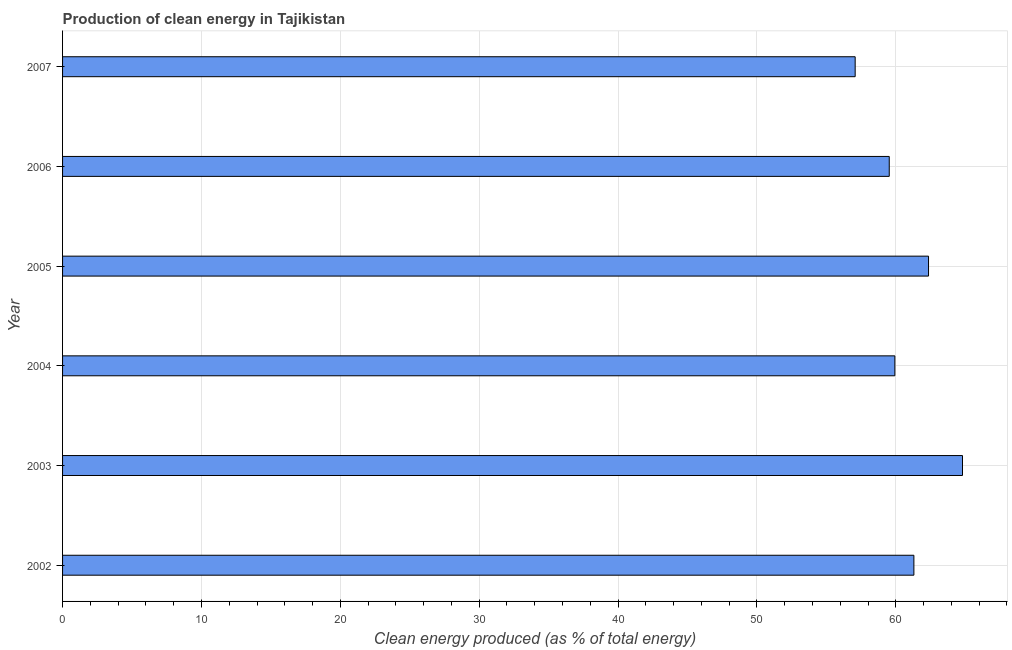Does the graph contain grids?
Provide a succinct answer. Yes. What is the title of the graph?
Your response must be concise. Production of clean energy in Tajikistan. What is the label or title of the X-axis?
Keep it short and to the point. Clean energy produced (as % of total energy). What is the production of clean energy in 2002?
Provide a short and direct response. 61.3. Across all years, what is the maximum production of clean energy?
Make the answer very short. 64.8. Across all years, what is the minimum production of clean energy?
Your answer should be very brief. 57.07. What is the sum of the production of clean energy?
Ensure brevity in your answer.  364.99. What is the difference between the production of clean energy in 2003 and 2006?
Offer a terse response. 5.27. What is the average production of clean energy per year?
Make the answer very short. 60.83. What is the median production of clean energy?
Give a very brief answer. 60.62. Do a majority of the years between 2003 and 2005 (inclusive) have production of clean energy greater than 20 %?
Give a very brief answer. Yes. Is the production of clean energy in 2005 less than that in 2007?
Ensure brevity in your answer.  No. Is the difference between the production of clean energy in 2004 and 2007 greater than the difference between any two years?
Provide a short and direct response. No. What is the difference between the highest and the second highest production of clean energy?
Ensure brevity in your answer.  2.45. What is the difference between the highest and the lowest production of clean energy?
Keep it short and to the point. 7.73. In how many years, is the production of clean energy greater than the average production of clean energy taken over all years?
Offer a terse response. 3. Are all the bars in the graph horizontal?
Your answer should be compact. Yes. How many years are there in the graph?
Your response must be concise. 6. What is the Clean energy produced (as % of total energy) in 2002?
Provide a short and direct response. 61.3. What is the Clean energy produced (as % of total energy) of 2003?
Provide a short and direct response. 64.8. What is the Clean energy produced (as % of total energy) of 2004?
Make the answer very short. 59.93. What is the Clean energy produced (as % of total energy) in 2005?
Your response must be concise. 62.35. What is the Clean energy produced (as % of total energy) of 2006?
Keep it short and to the point. 59.53. What is the Clean energy produced (as % of total energy) in 2007?
Offer a terse response. 57.07. What is the difference between the Clean energy produced (as % of total energy) in 2002 and 2003?
Provide a succinct answer. -3.5. What is the difference between the Clean energy produced (as % of total energy) in 2002 and 2004?
Your response must be concise. 1.37. What is the difference between the Clean energy produced (as % of total energy) in 2002 and 2005?
Make the answer very short. -1.05. What is the difference between the Clean energy produced (as % of total energy) in 2002 and 2006?
Provide a succinct answer. 1.77. What is the difference between the Clean energy produced (as % of total energy) in 2002 and 2007?
Provide a succinct answer. 4.23. What is the difference between the Clean energy produced (as % of total energy) in 2003 and 2004?
Provide a short and direct response. 4.87. What is the difference between the Clean energy produced (as % of total energy) in 2003 and 2005?
Your answer should be very brief. 2.45. What is the difference between the Clean energy produced (as % of total energy) in 2003 and 2006?
Make the answer very short. 5.27. What is the difference between the Clean energy produced (as % of total energy) in 2003 and 2007?
Your response must be concise. 7.73. What is the difference between the Clean energy produced (as % of total energy) in 2004 and 2005?
Give a very brief answer. -2.42. What is the difference between the Clean energy produced (as % of total energy) in 2004 and 2006?
Give a very brief answer. 0.4. What is the difference between the Clean energy produced (as % of total energy) in 2004 and 2007?
Your answer should be compact. 2.86. What is the difference between the Clean energy produced (as % of total energy) in 2005 and 2006?
Provide a short and direct response. 2.83. What is the difference between the Clean energy produced (as % of total energy) in 2005 and 2007?
Ensure brevity in your answer.  5.28. What is the difference between the Clean energy produced (as % of total energy) in 2006 and 2007?
Your answer should be compact. 2.45. What is the ratio of the Clean energy produced (as % of total energy) in 2002 to that in 2003?
Make the answer very short. 0.95. What is the ratio of the Clean energy produced (as % of total energy) in 2002 to that in 2007?
Make the answer very short. 1.07. What is the ratio of the Clean energy produced (as % of total energy) in 2003 to that in 2004?
Your answer should be compact. 1.08. What is the ratio of the Clean energy produced (as % of total energy) in 2003 to that in 2005?
Provide a short and direct response. 1.04. What is the ratio of the Clean energy produced (as % of total energy) in 2003 to that in 2006?
Provide a succinct answer. 1.09. What is the ratio of the Clean energy produced (as % of total energy) in 2003 to that in 2007?
Your answer should be very brief. 1.14. What is the ratio of the Clean energy produced (as % of total energy) in 2004 to that in 2006?
Offer a terse response. 1.01. What is the ratio of the Clean energy produced (as % of total energy) in 2004 to that in 2007?
Give a very brief answer. 1.05. What is the ratio of the Clean energy produced (as % of total energy) in 2005 to that in 2006?
Your response must be concise. 1.05. What is the ratio of the Clean energy produced (as % of total energy) in 2005 to that in 2007?
Keep it short and to the point. 1.09. What is the ratio of the Clean energy produced (as % of total energy) in 2006 to that in 2007?
Offer a terse response. 1.04. 